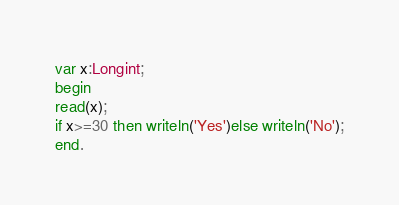<code> <loc_0><loc_0><loc_500><loc_500><_Pascal_>var x:Longint;
begin
read(x);
if x>=30 then writeln('Yes')else writeln('No');
end.</code> 